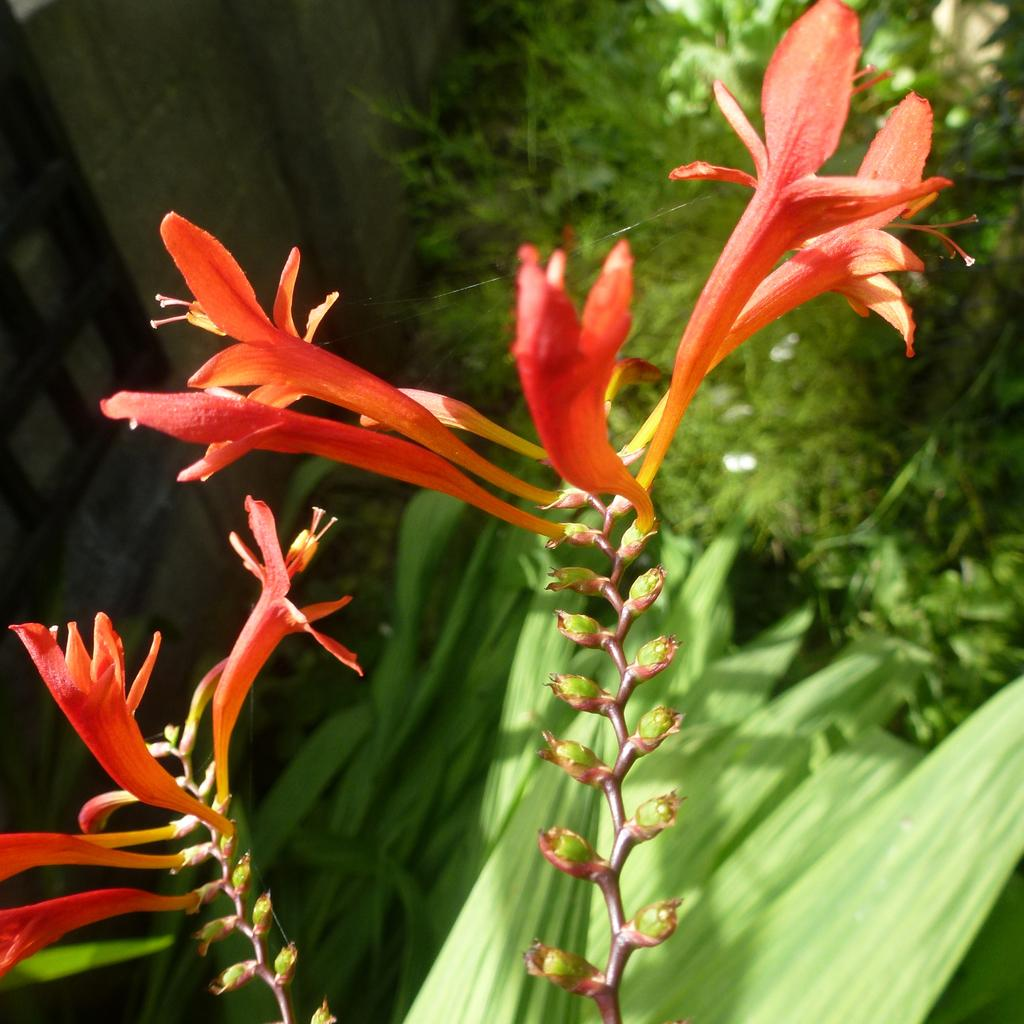What type of living organisms can be seen in the image? Plants and flowers can be seen in the image. Can you describe the flowers in the image? The flowers in the image are part of the plants. What type of disease can be seen affecting the plants in the image? There is no indication of any disease affecting the plants in the image. Can you tell me how many plant experts are visible in the image? There are no plant experts present in the image. 